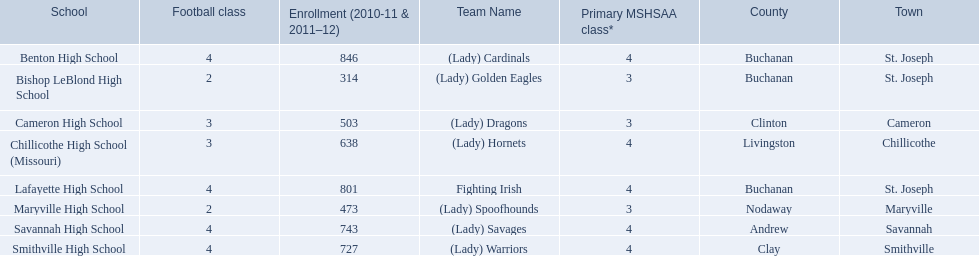What are the names of the schools? Benton High School, Bishop LeBlond High School, Cameron High School, Chillicothe High School (Missouri), Lafayette High School, Maryville High School, Savannah High School, Smithville High School. Of those, which had a total enrollment of less than 500? Bishop LeBlond High School, Maryville High School. And of those, which had the lowest enrollment? Bishop LeBlond High School. 